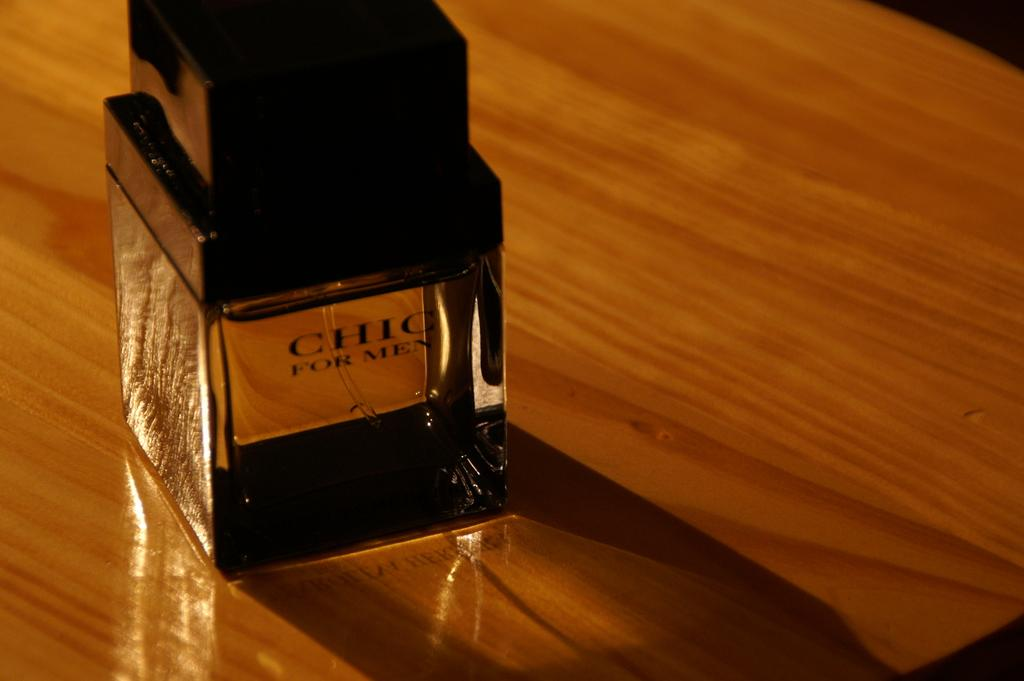<image>
Provide a brief description of the given image. bottle of chic for men on a wood table 